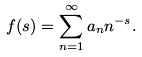Convert formula to latex. <formula><loc_0><loc_0><loc_500><loc_500>f ( s ) = \sum _ { n = 1 } ^ { \infty } a _ { n } n ^ { - s } .</formula> 